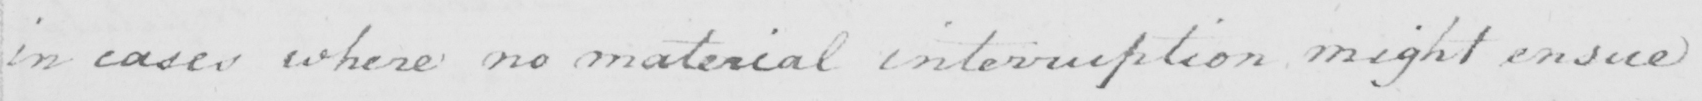Transcribe the text shown in this historical manuscript line. in cases where no material interruption might ensue 